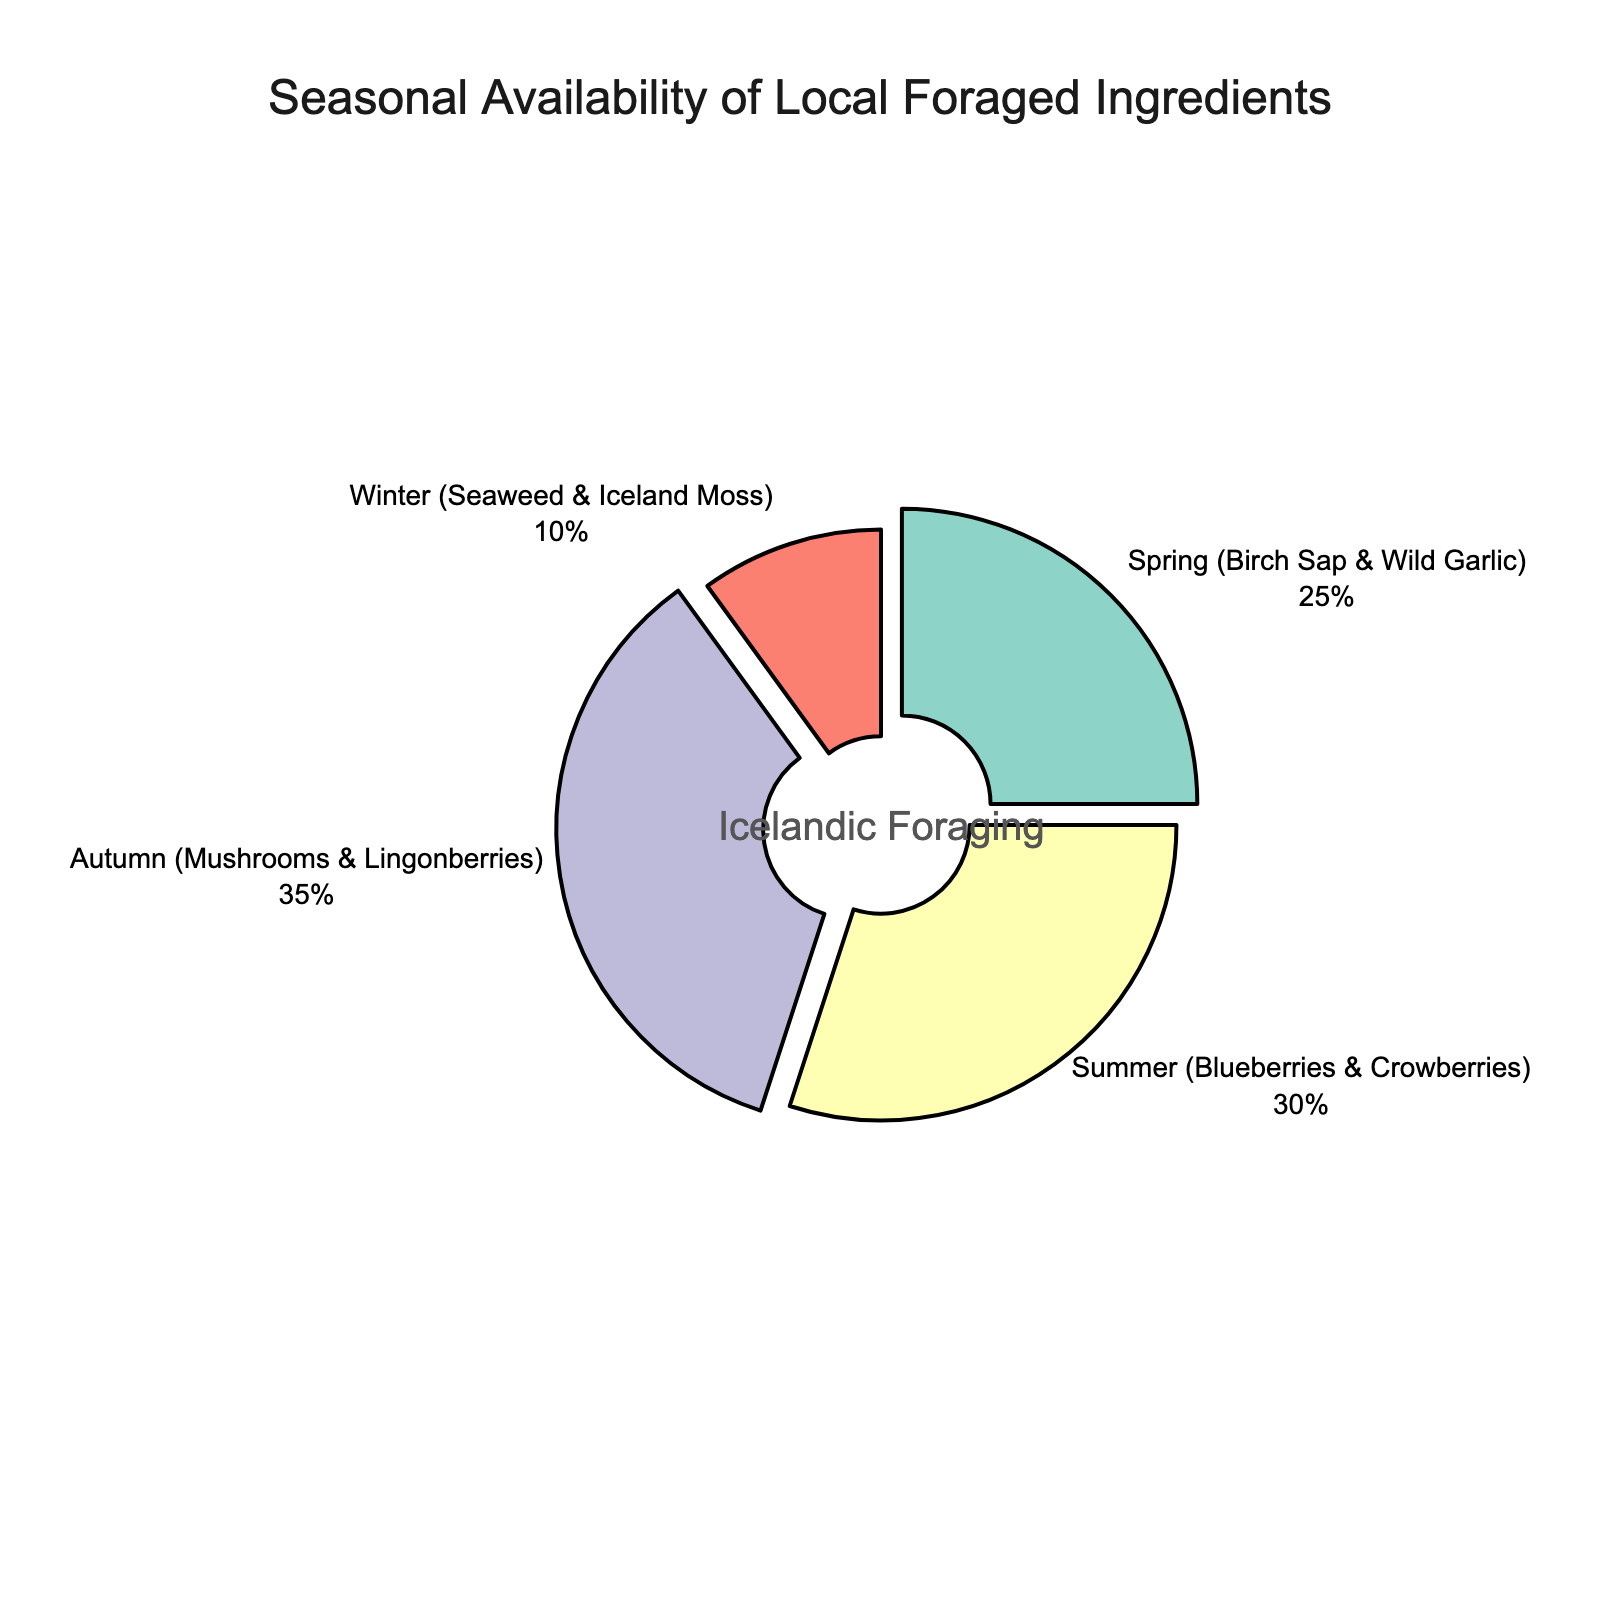Which season has the highest percentage of locally foraged ingredients? The 'Autumn (Mushrooms & Lingonberries)' section of the pie chart is the largest, indicating this season has the highest percentage.
Answer: Autumn (Mushrooms & Lingonberries) What is the combined percentage of local foraged ingredients available in Spring and Winter? Sum the percentages of Spring (25%) and Winter (10%): 25% + 10% = 35%.
Answer: 35% Which season has the lowest percentage of local foraged ingredients? The 'Winter (Seaweed & Iceland Moss)' section of the pie chart is the smallest, indicating this season has the lowest percentage.
Answer: Winter (Seaweed & Iceland Moss) How much larger is the percentage of Summer foraged ingredients compared to Winter? Subtract the Winter percentage (10%) from the Summer percentage (30%): 30% - 10% = 20%.
Answer: 20% What is the average percentage of local foraged ingredients across all seasons? Sum the percentages of all seasons and divide by the number of seasons: (25% + 30% + 35% + 10%) / 4 = 100% / 4 = 25%.
Answer: 25% Is the percentage of foraged ingredients in Autumn greater than the sum of those in Spring and Winter? Compare Autumn's percentage (35%) with the combined percentage of Spring and Winter (25% + 10% = 35%). 35% is equal to 35%.
Answer: No Arrange the seasons in descending order according to the availability of local foraged ingredients. Observing the pie chart, the order from highest to lowest percentage is: Autumn (35%), Summer (30%), Spring (25%), Winter (10%).
Answer: Autumn, Summer, Spring, Winter What percentage of local foraged ingredients are available in the non-autumn months? Sum the percentages of Spring, Summer, and Winter: 25% + 30% + 10% = 65%.
Answer: 65% Which two seasons together contribute 60% of the local foraged ingredients availability? Looking at the chart, combining Spring (25%) and Summer (30%) plus Winter (10%) is either less or greater than 60%. However, Autumn (35%) and Summer (30%) sum to 65%. Thus, Spring (25%) and Summer (30%) are closest to 60%, with a total of 55%.
Answer: No exact match (closest: Spring and Summer with 55%) What color represents the Summer season in the pie chart? The Summer (Blueberries & Crowberries) section is represented by the color 'yellow'.
Answer: Yellow 